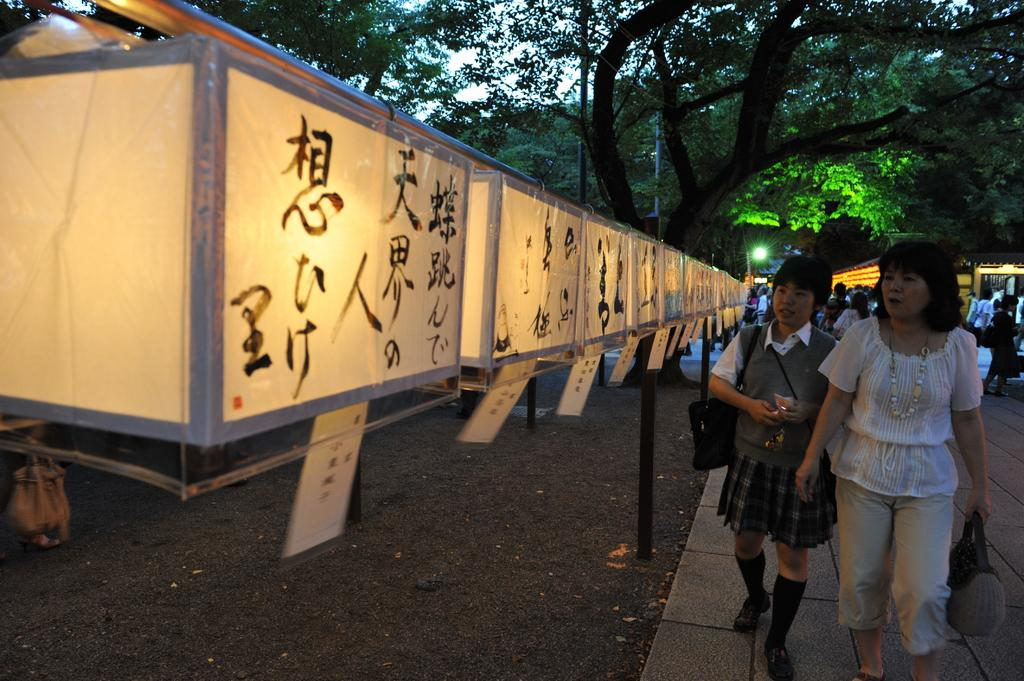How many people are in the image? There are two persons in the image. What are the persons wearing? The persons are wearing clothes. What are the persons doing in the image? The persons are walking beside boxes. What is inside the boxes? The boxes contain lights. What can be seen in the background of the image? There is a tree at the top of the image. Where is the nearest seat to the persons in the image? There is no mention of a seat in the image, so it cannot be determined where the nearest seat is. 